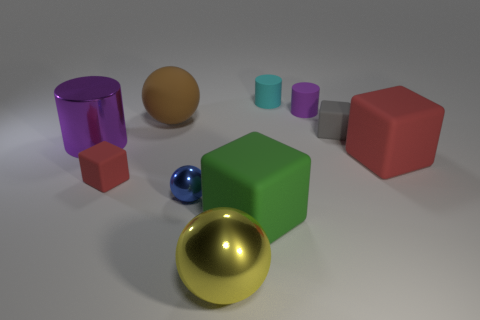Subtract all balls. How many objects are left? 7 Add 3 big brown spheres. How many big brown spheres are left? 4 Add 9 small brown matte things. How many small brown matte things exist? 9 Subtract 0 gray cylinders. How many objects are left? 10 Subtract all small blocks. Subtract all yellow shiny spheres. How many objects are left? 7 